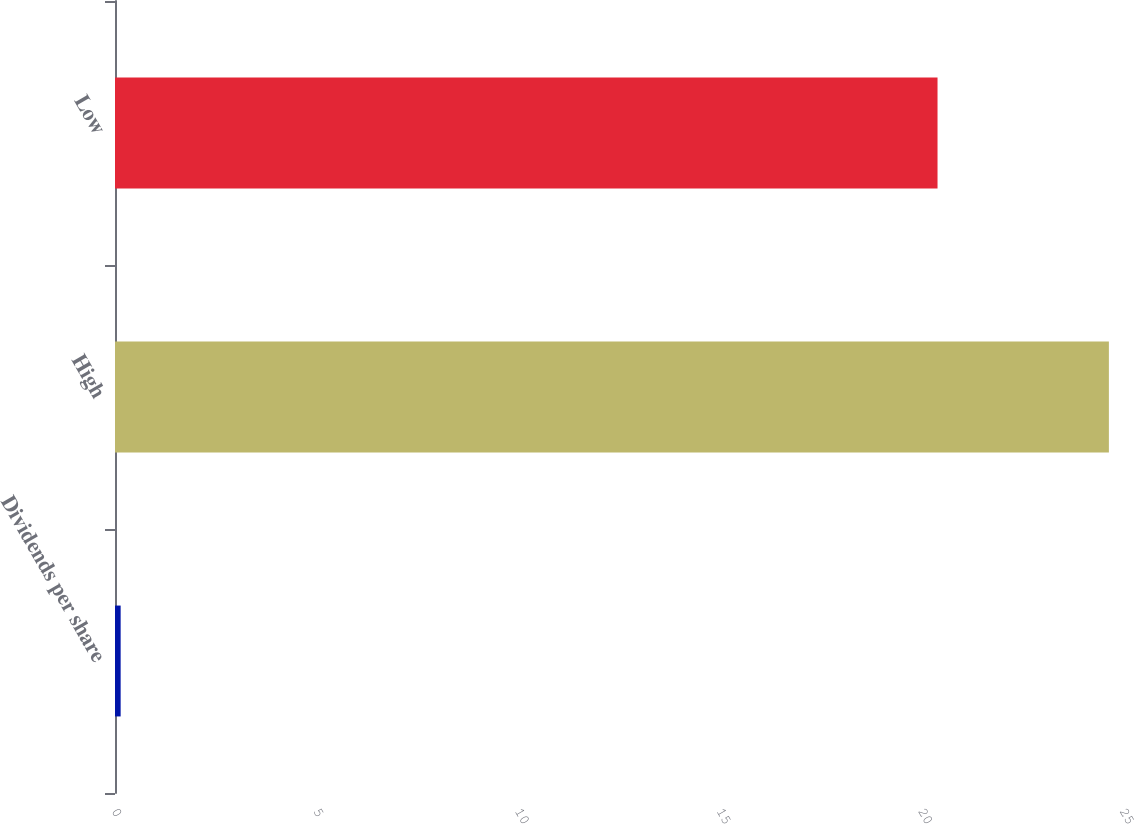Convert chart. <chart><loc_0><loc_0><loc_500><loc_500><bar_chart><fcel>Dividends per share<fcel>High<fcel>Low<nl><fcel>0.14<fcel>24.65<fcel>20.4<nl></chart> 